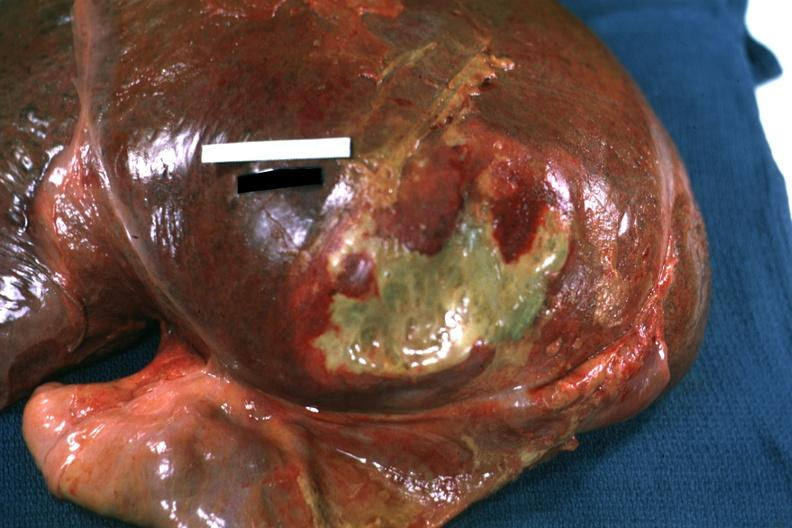does lymphoma show right leaf of diaphragm reflected to show flat mass of yellow green pus quite good example?
Answer the question using a single word or phrase. No 